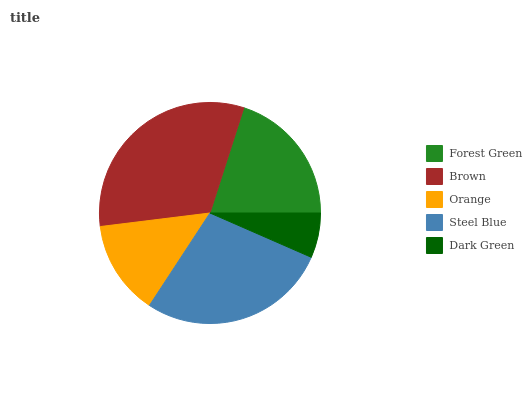Is Dark Green the minimum?
Answer yes or no. Yes. Is Brown the maximum?
Answer yes or no. Yes. Is Orange the minimum?
Answer yes or no. No. Is Orange the maximum?
Answer yes or no. No. Is Brown greater than Orange?
Answer yes or no. Yes. Is Orange less than Brown?
Answer yes or no. Yes. Is Orange greater than Brown?
Answer yes or no. No. Is Brown less than Orange?
Answer yes or no. No. Is Forest Green the high median?
Answer yes or no. Yes. Is Forest Green the low median?
Answer yes or no. Yes. Is Dark Green the high median?
Answer yes or no. No. Is Steel Blue the low median?
Answer yes or no. No. 